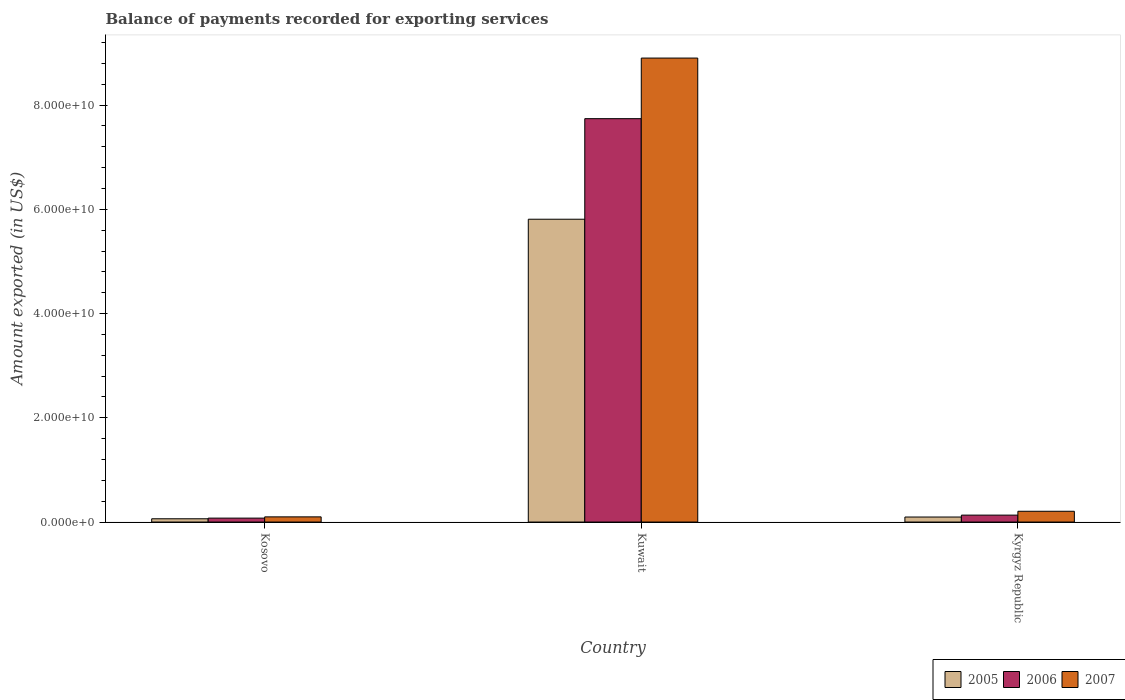How many different coloured bars are there?
Keep it short and to the point. 3. How many groups of bars are there?
Your response must be concise. 3. What is the label of the 3rd group of bars from the left?
Your answer should be very brief. Kyrgyz Republic. In how many cases, is the number of bars for a given country not equal to the number of legend labels?
Offer a very short reply. 0. What is the amount exported in 2006 in Kuwait?
Keep it short and to the point. 7.74e+1. Across all countries, what is the maximum amount exported in 2006?
Make the answer very short. 7.74e+1. Across all countries, what is the minimum amount exported in 2005?
Ensure brevity in your answer.  6.25e+08. In which country was the amount exported in 2006 maximum?
Offer a terse response. Kuwait. In which country was the amount exported in 2007 minimum?
Provide a succinct answer. Kosovo. What is the total amount exported in 2006 in the graph?
Give a very brief answer. 7.95e+1. What is the difference between the amount exported in 2005 in Kosovo and that in Kuwait?
Offer a terse response. -5.75e+1. What is the difference between the amount exported in 2007 in Kyrgyz Republic and the amount exported in 2006 in Kuwait?
Make the answer very short. -7.53e+1. What is the average amount exported in 2006 per country?
Offer a very short reply. 2.65e+1. What is the difference between the amount exported of/in 2005 and amount exported of/in 2007 in Kyrgyz Republic?
Ensure brevity in your answer.  -1.10e+09. What is the ratio of the amount exported in 2006 in Kuwait to that in Kyrgyz Republic?
Offer a terse response. 58.35. Is the difference between the amount exported in 2005 in Kosovo and Kuwait greater than the difference between the amount exported in 2007 in Kosovo and Kuwait?
Make the answer very short. Yes. What is the difference between the highest and the second highest amount exported in 2006?
Offer a very short reply. -7.66e+1. What is the difference between the highest and the lowest amount exported in 2007?
Provide a succinct answer. 8.80e+1. What does the 2nd bar from the right in Kuwait represents?
Your response must be concise. 2006. How many bars are there?
Ensure brevity in your answer.  9. Are all the bars in the graph horizontal?
Make the answer very short. No. How many countries are there in the graph?
Provide a short and direct response. 3. What is the difference between two consecutive major ticks on the Y-axis?
Your answer should be very brief. 2.00e+1. Does the graph contain any zero values?
Your answer should be compact. No. Does the graph contain grids?
Your answer should be compact. No. How many legend labels are there?
Provide a succinct answer. 3. How are the legend labels stacked?
Provide a succinct answer. Horizontal. What is the title of the graph?
Make the answer very short. Balance of payments recorded for exporting services. Does "2007" appear as one of the legend labels in the graph?
Keep it short and to the point. Yes. What is the label or title of the Y-axis?
Your response must be concise. Amount exported (in US$). What is the Amount exported (in US$) of 2005 in Kosovo?
Give a very brief answer. 6.25e+08. What is the Amount exported (in US$) in 2006 in Kosovo?
Offer a terse response. 7.50e+08. What is the Amount exported (in US$) of 2007 in Kosovo?
Offer a very short reply. 9.91e+08. What is the Amount exported (in US$) of 2005 in Kuwait?
Provide a short and direct response. 5.81e+1. What is the Amount exported (in US$) of 2006 in Kuwait?
Provide a succinct answer. 7.74e+1. What is the Amount exported (in US$) in 2007 in Kuwait?
Provide a succinct answer. 8.90e+1. What is the Amount exported (in US$) in 2005 in Kyrgyz Republic?
Your answer should be compact. 9.63e+08. What is the Amount exported (in US$) of 2006 in Kyrgyz Republic?
Ensure brevity in your answer.  1.33e+09. What is the Amount exported (in US$) in 2007 in Kyrgyz Republic?
Make the answer very short. 2.07e+09. Across all countries, what is the maximum Amount exported (in US$) of 2005?
Provide a succinct answer. 5.81e+1. Across all countries, what is the maximum Amount exported (in US$) of 2006?
Make the answer very short. 7.74e+1. Across all countries, what is the maximum Amount exported (in US$) in 2007?
Offer a very short reply. 8.90e+1. Across all countries, what is the minimum Amount exported (in US$) of 2005?
Your answer should be very brief. 6.25e+08. Across all countries, what is the minimum Amount exported (in US$) in 2006?
Provide a succinct answer. 7.50e+08. Across all countries, what is the minimum Amount exported (in US$) in 2007?
Give a very brief answer. 9.91e+08. What is the total Amount exported (in US$) in 2005 in the graph?
Give a very brief answer. 5.97e+1. What is the total Amount exported (in US$) in 2006 in the graph?
Your response must be concise. 7.95e+1. What is the total Amount exported (in US$) in 2007 in the graph?
Give a very brief answer. 9.21e+1. What is the difference between the Amount exported (in US$) in 2005 in Kosovo and that in Kuwait?
Provide a short and direct response. -5.75e+1. What is the difference between the Amount exported (in US$) of 2006 in Kosovo and that in Kuwait?
Provide a succinct answer. -7.66e+1. What is the difference between the Amount exported (in US$) in 2007 in Kosovo and that in Kuwait?
Provide a succinct answer. -8.80e+1. What is the difference between the Amount exported (in US$) in 2005 in Kosovo and that in Kyrgyz Republic?
Your answer should be very brief. -3.38e+08. What is the difference between the Amount exported (in US$) in 2006 in Kosovo and that in Kyrgyz Republic?
Your answer should be very brief. -5.76e+08. What is the difference between the Amount exported (in US$) of 2007 in Kosovo and that in Kyrgyz Republic?
Your answer should be very brief. -1.07e+09. What is the difference between the Amount exported (in US$) of 2005 in Kuwait and that in Kyrgyz Republic?
Ensure brevity in your answer.  5.71e+1. What is the difference between the Amount exported (in US$) of 2006 in Kuwait and that in Kyrgyz Republic?
Provide a succinct answer. 7.61e+1. What is the difference between the Amount exported (in US$) in 2007 in Kuwait and that in Kyrgyz Republic?
Offer a very short reply. 8.70e+1. What is the difference between the Amount exported (in US$) in 2005 in Kosovo and the Amount exported (in US$) in 2006 in Kuwait?
Your answer should be very brief. -7.68e+1. What is the difference between the Amount exported (in US$) in 2005 in Kosovo and the Amount exported (in US$) in 2007 in Kuwait?
Keep it short and to the point. -8.84e+1. What is the difference between the Amount exported (in US$) of 2006 in Kosovo and the Amount exported (in US$) of 2007 in Kuwait?
Offer a very short reply. -8.83e+1. What is the difference between the Amount exported (in US$) in 2005 in Kosovo and the Amount exported (in US$) in 2006 in Kyrgyz Republic?
Ensure brevity in your answer.  -7.02e+08. What is the difference between the Amount exported (in US$) in 2005 in Kosovo and the Amount exported (in US$) in 2007 in Kyrgyz Republic?
Make the answer very short. -1.44e+09. What is the difference between the Amount exported (in US$) of 2006 in Kosovo and the Amount exported (in US$) of 2007 in Kyrgyz Republic?
Your response must be concise. -1.31e+09. What is the difference between the Amount exported (in US$) of 2005 in Kuwait and the Amount exported (in US$) of 2006 in Kyrgyz Republic?
Provide a succinct answer. 5.68e+1. What is the difference between the Amount exported (in US$) in 2005 in Kuwait and the Amount exported (in US$) in 2007 in Kyrgyz Republic?
Your answer should be compact. 5.60e+1. What is the difference between the Amount exported (in US$) of 2006 in Kuwait and the Amount exported (in US$) of 2007 in Kyrgyz Republic?
Keep it short and to the point. 7.53e+1. What is the average Amount exported (in US$) in 2005 per country?
Give a very brief answer. 1.99e+1. What is the average Amount exported (in US$) in 2006 per country?
Provide a short and direct response. 2.65e+1. What is the average Amount exported (in US$) of 2007 per country?
Make the answer very short. 3.07e+1. What is the difference between the Amount exported (in US$) of 2005 and Amount exported (in US$) of 2006 in Kosovo?
Offer a very short reply. -1.26e+08. What is the difference between the Amount exported (in US$) in 2005 and Amount exported (in US$) in 2007 in Kosovo?
Keep it short and to the point. -3.66e+08. What is the difference between the Amount exported (in US$) of 2006 and Amount exported (in US$) of 2007 in Kosovo?
Your response must be concise. -2.40e+08. What is the difference between the Amount exported (in US$) of 2005 and Amount exported (in US$) of 2006 in Kuwait?
Offer a very short reply. -1.93e+1. What is the difference between the Amount exported (in US$) of 2005 and Amount exported (in US$) of 2007 in Kuwait?
Give a very brief answer. -3.09e+1. What is the difference between the Amount exported (in US$) in 2006 and Amount exported (in US$) in 2007 in Kuwait?
Give a very brief answer. -1.16e+1. What is the difference between the Amount exported (in US$) in 2005 and Amount exported (in US$) in 2006 in Kyrgyz Republic?
Provide a short and direct response. -3.64e+08. What is the difference between the Amount exported (in US$) of 2005 and Amount exported (in US$) of 2007 in Kyrgyz Republic?
Your answer should be compact. -1.10e+09. What is the difference between the Amount exported (in US$) in 2006 and Amount exported (in US$) in 2007 in Kyrgyz Republic?
Ensure brevity in your answer.  -7.39e+08. What is the ratio of the Amount exported (in US$) of 2005 in Kosovo to that in Kuwait?
Offer a very short reply. 0.01. What is the ratio of the Amount exported (in US$) of 2006 in Kosovo to that in Kuwait?
Keep it short and to the point. 0.01. What is the ratio of the Amount exported (in US$) of 2007 in Kosovo to that in Kuwait?
Your answer should be very brief. 0.01. What is the ratio of the Amount exported (in US$) of 2005 in Kosovo to that in Kyrgyz Republic?
Provide a succinct answer. 0.65. What is the ratio of the Amount exported (in US$) in 2006 in Kosovo to that in Kyrgyz Republic?
Give a very brief answer. 0.57. What is the ratio of the Amount exported (in US$) in 2007 in Kosovo to that in Kyrgyz Republic?
Your answer should be compact. 0.48. What is the ratio of the Amount exported (in US$) in 2005 in Kuwait to that in Kyrgyz Republic?
Make the answer very short. 60.35. What is the ratio of the Amount exported (in US$) in 2006 in Kuwait to that in Kyrgyz Republic?
Make the answer very short. 58.35. What is the ratio of the Amount exported (in US$) in 2007 in Kuwait to that in Kyrgyz Republic?
Give a very brief answer. 43.1. What is the difference between the highest and the second highest Amount exported (in US$) in 2005?
Offer a very short reply. 5.71e+1. What is the difference between the highest and the second highest Amount exported (in US$) of 2006?
Your answer should be compact. 7.61e+1. What is the difference between the highest and the second highest Amount exported (in US$) of 2007?
Your response must be concise. 8.70e+1. What is the difference between the highest and the lowest Amount exported (in US$) of 2005?
Offer a terse response. 5.75e+1. What is the difference between the highest and the lowest Amount exported (in US$) in 2006?
Offer a very short reply. 7.66e+1. What is the difference between the highest and the lowest Amount exported (in US$) of 2007?
Offer a terse response. 8.80e+1. 